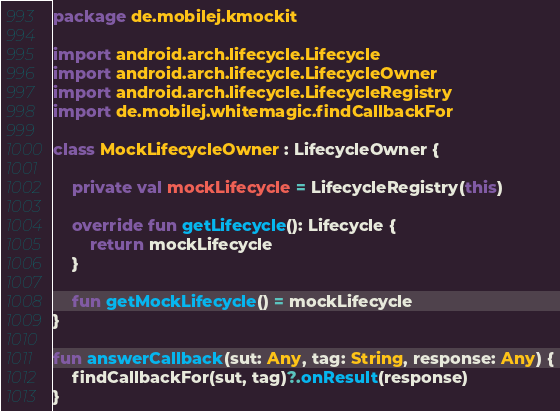<code> <loc_0><loc_0><loc_500><loc_500><_Kotlin_>package de.mobilej.kmockit

import android.arch.lifecycle.Lifecycle
import android.arch.lifecycle.LifecycleOwner
import android.arch.lifecycle.LifecycleRegistry
import de.mobilej.whitemagic.findCallbackFor

class MockLifecycleOwner : LifecycleOwner {

    private val mockLifecycle = LifecycleRegistry(this)

    override fun getLifecycle(): Lifecycle {
        return mockLifecycle
    }

    fun getMockLifecycle() = mockLifecycle
}

fun answerCallback(sut: Any, tag: String, response: Any) {
    findCallbackFor(sut, tag)?.onResult(response)
}</code> 